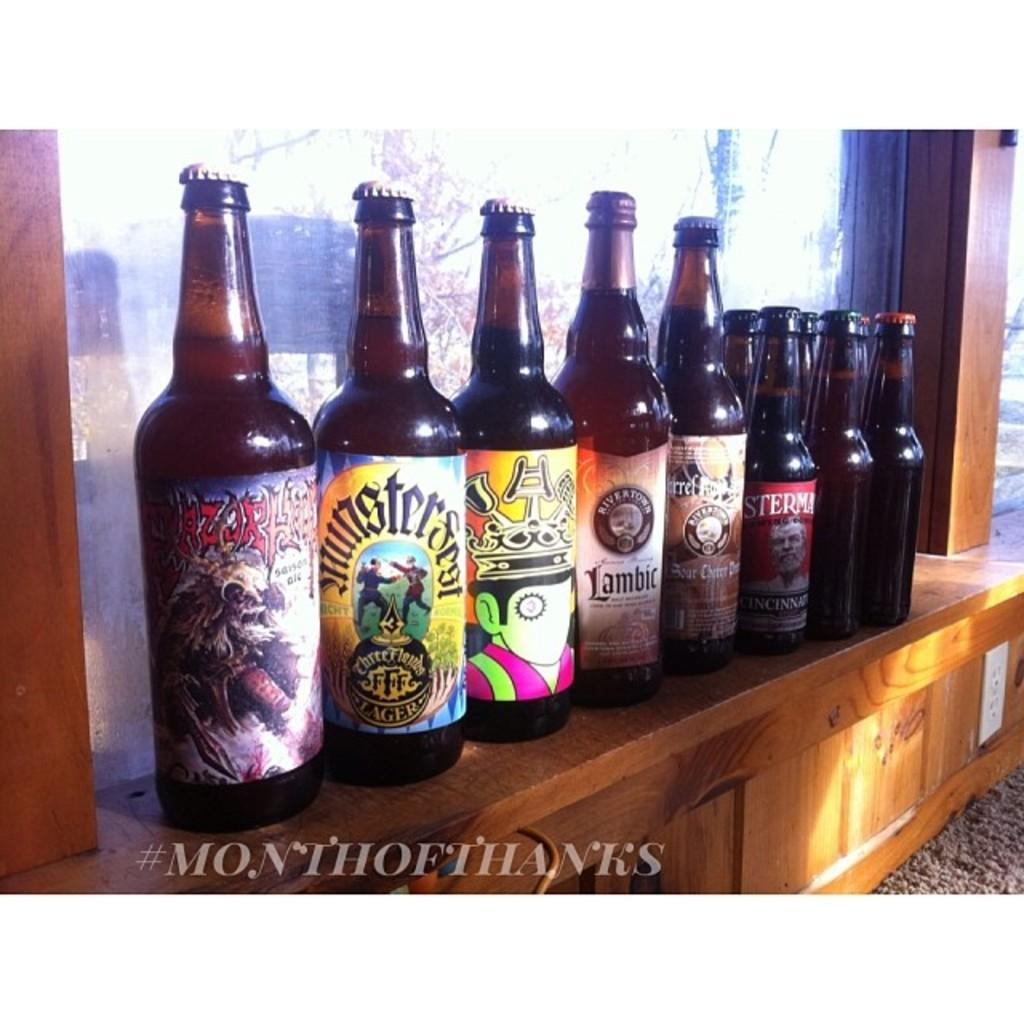<image>
Relay a brief, clear account of the picture shown. a row of alcohol bottles  with one that is labeled 'amsterman' 